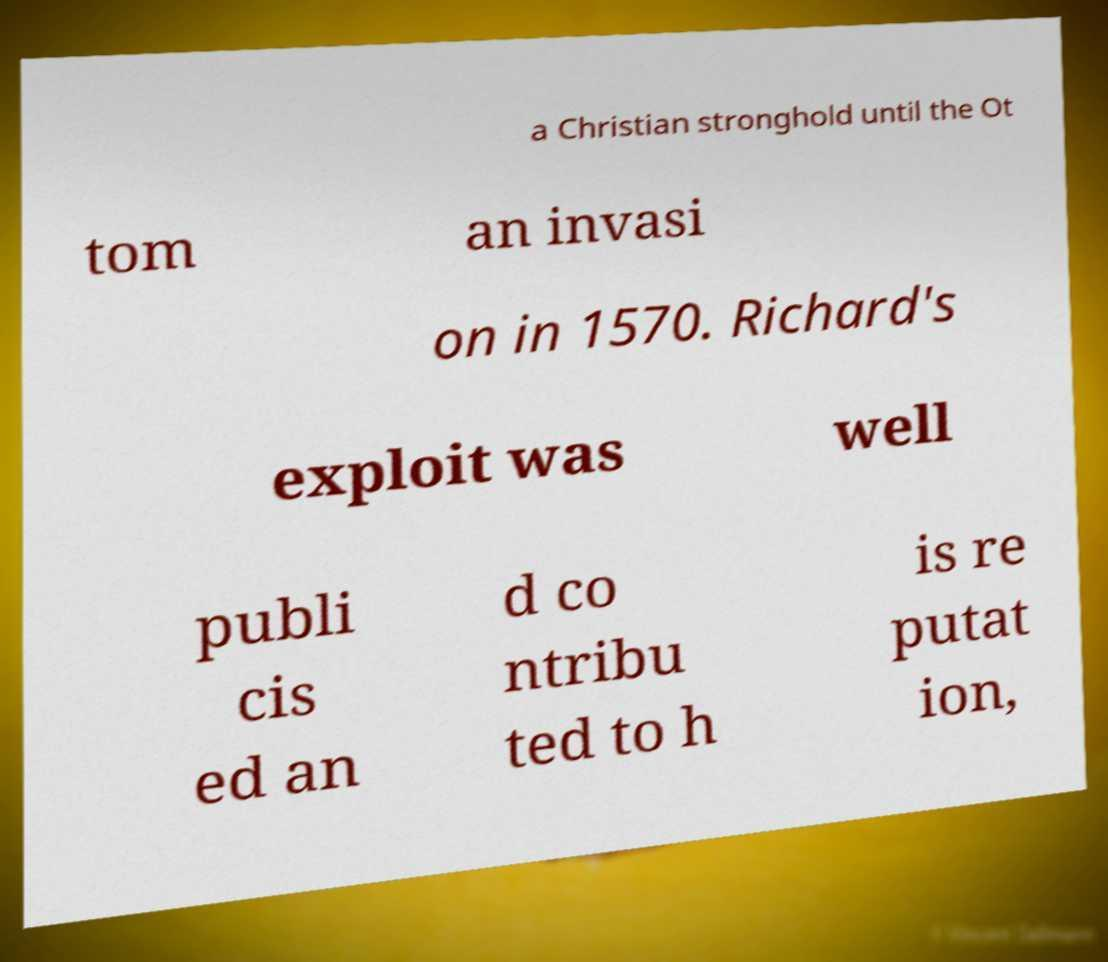What messages or text are displayed in this image? I need them in a readable, typed format. a Christian stronghold until the Ot tom an invasi on in 1570. Richard's exploit was well publi cis ed an d co ntribu ted to h is re putat ion, 